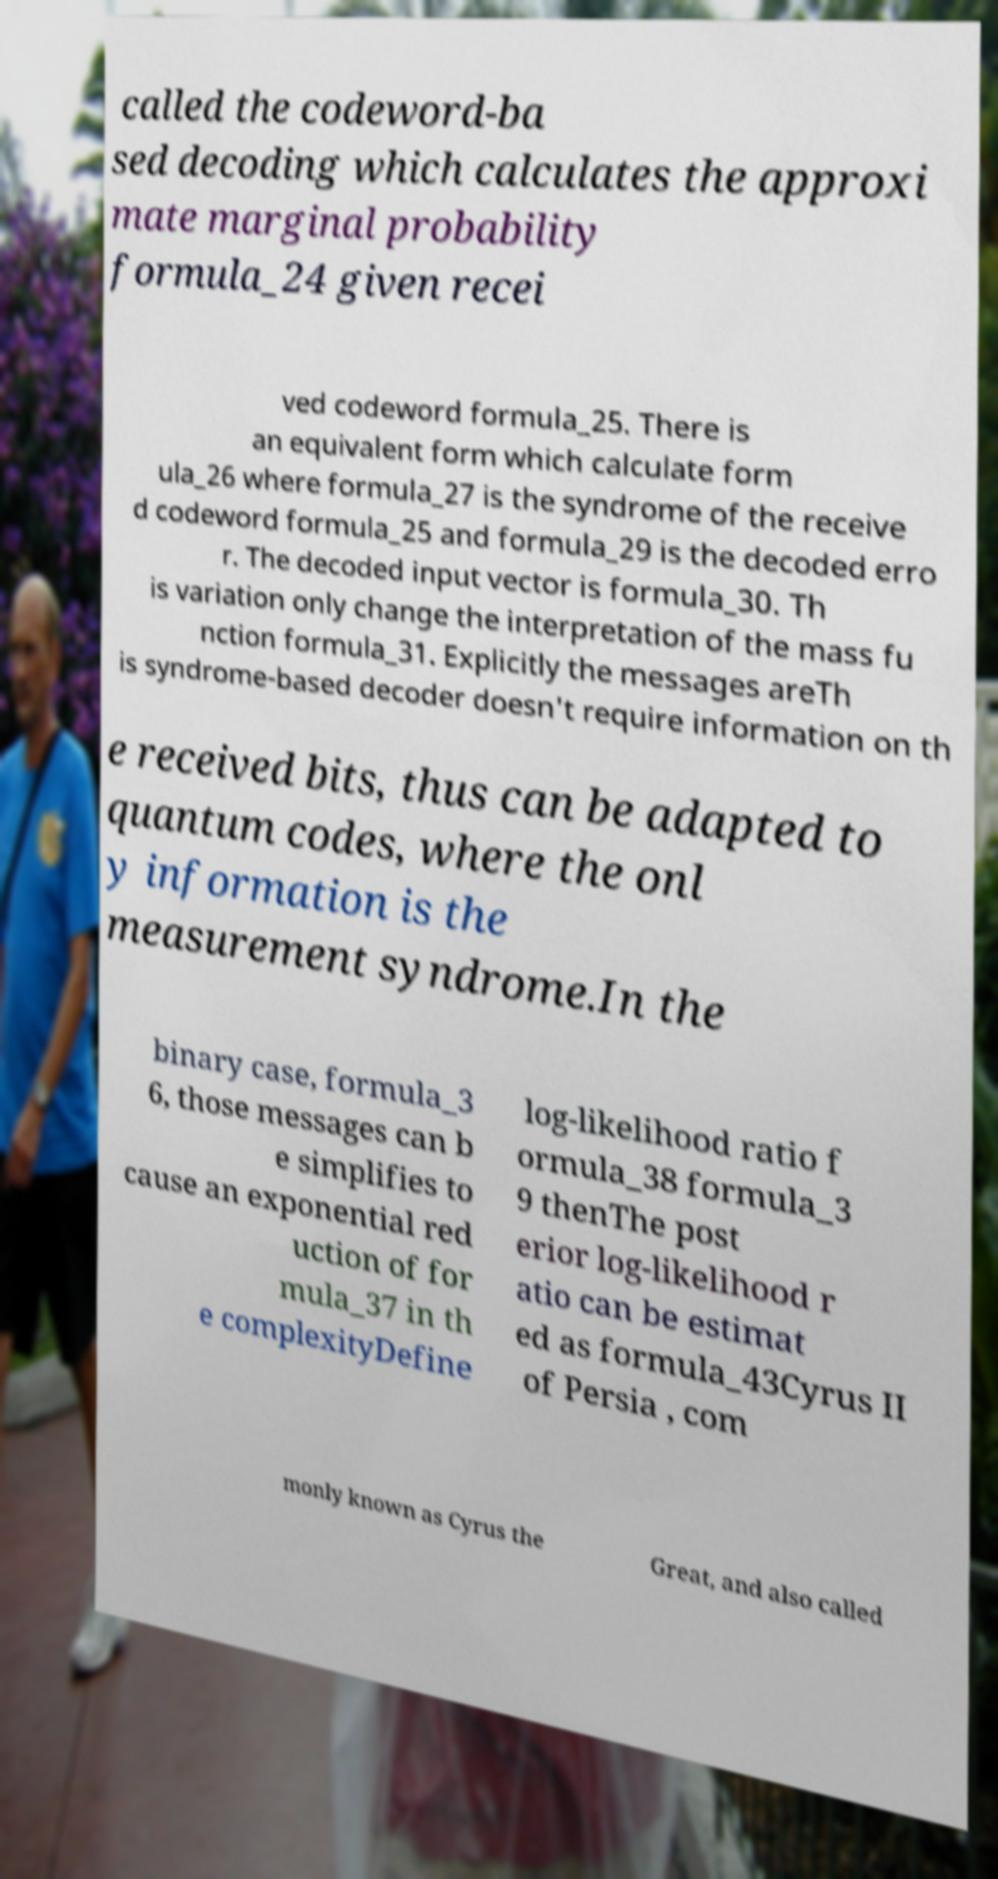Could you assist in decoding the text presented in this image and type it out clearly? called the codeword-ba sed decoding which calculates the approxi mate marginal probability formula_24 given recei ved codeword formula_25. There is an equivalent form which calculate form ula_26 where formula_27 is the syndrome of the receive d codeword formula_25 and formula_29 is the decoded erro r. The decoded input vector is formula_30. Th is variation only change the interpretation of the mass fu nction formula_31. Explicitly the messages areTh is syndrome-based decoder doesn't require information on th e received bits, thus can be adapted to quantum codes, where the onl y information is the measurement syndrome.In the binary case, formula_3 6, those messages can b e simplifies to cause an exponential red uction of for mula_37 in th e complexityDefine log-likelihood ratio f ormula_38 formula_3 9 thenThe post erior log-likelihood r atio can be estimat ed as formula_43Cyrus II of Persia , com monly known as Cyrus the Great, and also called 